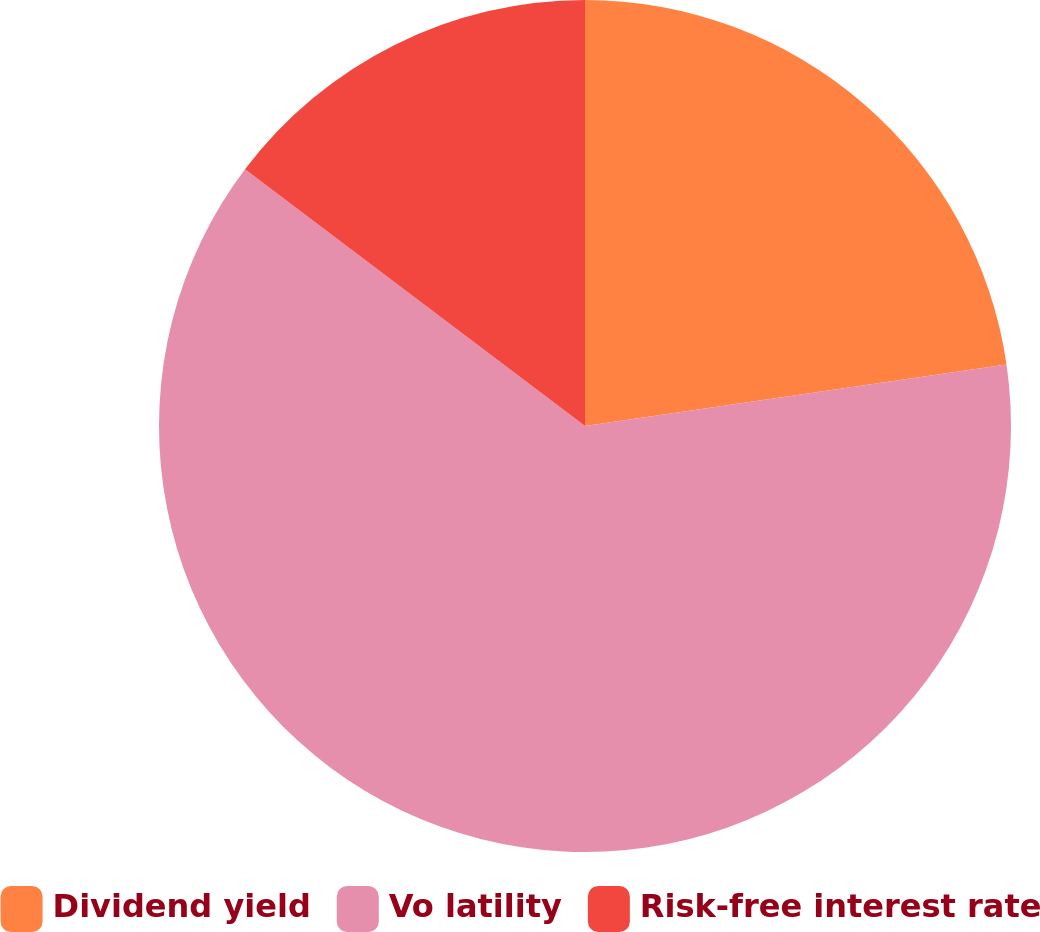<chart> <loc_0><loc_0><loc_500><loc_500><pie_chart><fcel>Dividend yield<fcel>Vo latility<fcel>Risk-free interest rate<nl><fcel>22.69%<fcel>62.6%<fcel>14.71%<nl></chart> 